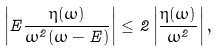Convert formula to latex. <formula><loc_0><loc_0><loc_500><loc_500>\left | E \frac { \eta ( \omega ) } { \omega ^ { 2 } ( \omega - E ) } \right | \leq 2 \left | \frac { \eta ( \omega ) } { \omega ^ { 2 } } \right | ,</formula> 